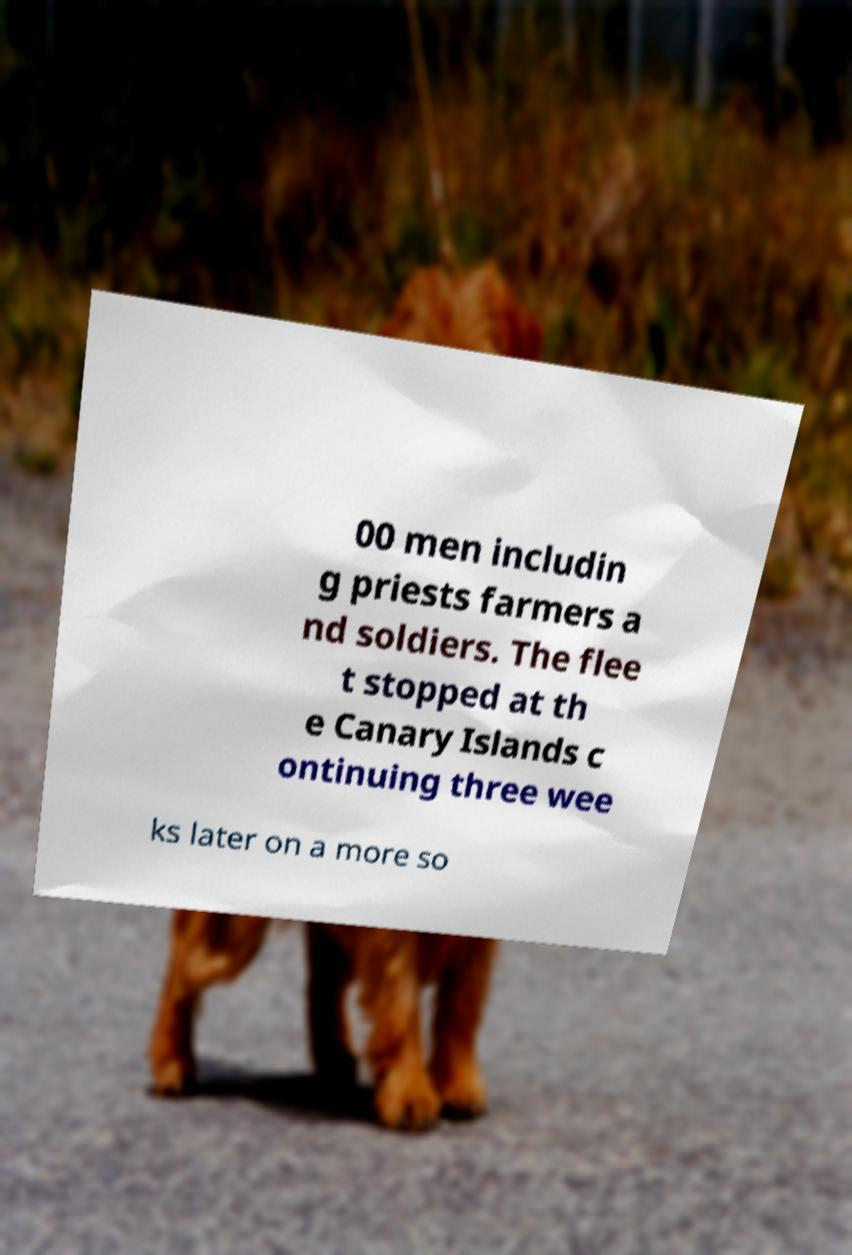Could you assist in decoding the text presented in this image and type it out clearly? 00 men includin g priests farmers a nd soldiers. The flee t stopped at th e Canary Islands c ontinuing three wee ks later on a more so 